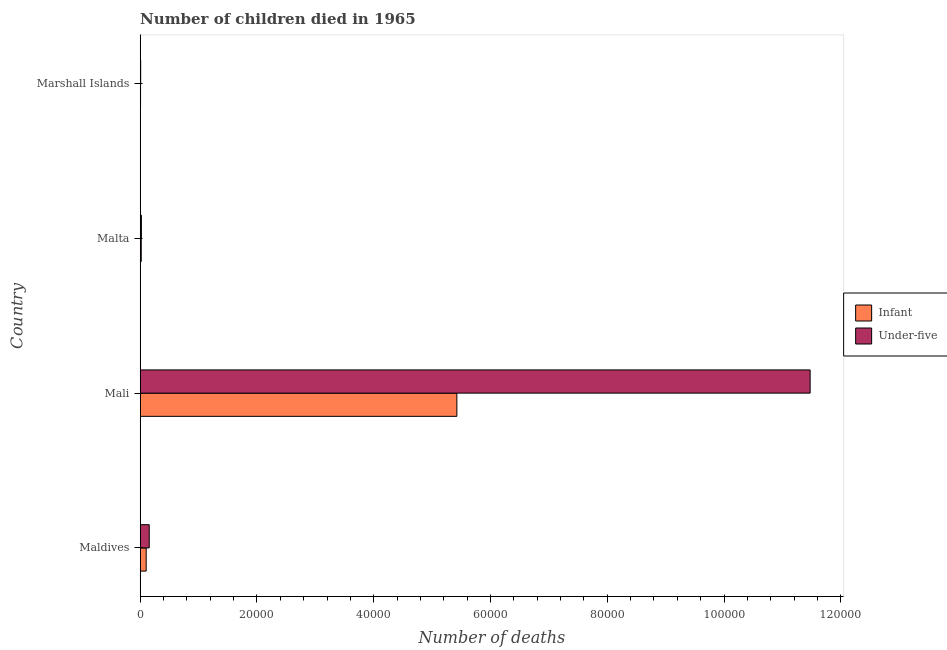How many groups of bars are there?
Ensure brevity in your answer.  4. Are the number of bars on each tick of the Y-axis equal?
Your answer should be compact. Yes. What is the label of the 4th group of bars from the top?
Ensure brevity in your answer.  Maldives. What is the number of infant deaths in Malta?
Your response must be concise. 174. Across all countries, what is the maximum number of infant deaths?
Ensure brevity in your answer.  5.42e+04. Across all countries, what is the minimum number of infant deaths?
Keep it short and to the point. 55. In which country was the number of infant deaths maximum?
Make the answer very short. Mali. In which country was the number of infant deaths minimum?
Offer a very short reply. Marshall Islands. What is the total number of under-five deaths in the graph?
Your answer should be very brief. 1.17e+05. What is the difference between the number of under-five deaths in Maldives and that in Marshall Islands?
Your answer should be compact. 1467. What is the difference between the number of under-five deaths in Mali and the number of infant deaths in Marshall Islands?
Keep it short and to the point. 1.15e+05. What is the average number of infant deaths per country?
Your answer should be compact. 1.39e+04. What is the difference between the number of infant deaths and number of under-five deaths in Marshall Islands?
Your answer should be very brief. -21. In how many countries, is the number of under-five deaths greater than 88000 ?
Provide a short and direct response. 1. What is the ratio of the number of under-five deaths in Mali to that in Marshall Islands?
Offer a very short reply. 1509.86. What is the difference between the highest and the second highest number of under-five deaths?
Your answer should be compact. 1.13e+05. What is the difference between the highest and the lowest number of infant deaths?
Keep it short and to the point. 5.42e+04. Is the sum of the number of under-five deaths in Mali and Marshall Islands greater than the maximum number of infant deaths across all countries?
Make the answer very short. Yes. What does the 2nd bar from the top in Malta represents?
Provide a short and direct response. Infant. What does the 1st bar from the bottom in Marshall Islands represents?
Provide a short and direct response. Infant. Are all the bars in the graph horizontal?
Provide a succinct answer. Yes. What is the difference between two consecutive major ticks on the X-axis?
Provide a succinct answer. 2.00e+04. Does the graph contain grids?
Keep it short and to the point. No. Where does the legend appear in the graph?
Provide a short and direct response. Center right. How are the legend labels stacked?
Your answer should be compact. Vertical. What is the title of the graph?
Your answer should be compact. Number of children died in 1965. What is the label or title of the X-axis?
Ensure brevity in your answer.  Number of deaths. What is the label or title of the Y-axis?
Offer a terse response. Country. What is the Number of deaths in Infant in Maldives?
Provide a short and direct response. 1022. What is the Number of deaths of Under-five in Maldives?
Your response must be concise. 1543. What is the Number of deaths of Infant in Mali?
Your response must be concise. 5.42e+04. What is the Number of deaths of Under-five in Mali?
Keep it short and to the point. 1.15e+05. What is the Number of deaths in Infant in Malta?
Your answer should be very brief. 174. What is the Number of deaths in Under-five in Malta?
Give a very brief answer. 200. What is the Number of deaths of Under-five in Marshall Islands?
Make the answer very short. 76. Across all countries, what is the maximum Number of deaths in Infant?
Make the answer very short. 5.42e+04. Across all countries, what is the maximum Number of deaths in Under-five?
Your answer should be compact. 1.15e+05. What is the total Number of deaths in Infant in the graph?
Provide a short and direct response. 5.55e+04. What is the total Number of deaths of Under-five in the graph?
Offer a very short reply. 1.17e+05. What is the difference between the Number of deaths in Infant in Maldives and that in Mali?
Your response must be concise. -5.32e+04. What is the difference between the Number of deaths in Under-five in Maldives and that in Mali?
Give a very brief answer. -1.13e+05. What is the difference between the Number of deaths of Infant in Maldives and that in Malta?
Keep it short and to the point. 848. What is the difference between the Number of deaths of Under-five in Maldives and that in Malta?
Give a very brief answer. 1343. What is the difference between the Number of deaths in Infant in Maldives and that in Marshall Islands?
Offer a very short reply. 967. What is the difference between the Number of deaths of Under-five in Maldives and that in Marshall Islands?
Your response must be concise. 1467. What is the difference between the Number of deaths in Infant in Mali and that in Malta?
Ensure brevity in your answer.  5.41e+04. What is the difference between the Number of deaths of Under-five in Mali and that in Malta?
Your answer should be compact. 1.15e+05. What is the difference between the Number of deaths of Infant in Mali and that in Marshall Islands?
Your response must be concise. 5.42e+04. What is the difference between the Number of deaths in Under-five in Mali and that in Marshall Islands?
Your response must be concise. 1.15e+05. What is the difference between the Number of deaths in Infant in Malta and that in Marshall Islands?
Give a very brief answer. 119. What is the difference between the Number of deaths in Under-five in Malta and that in Marshall Islands?
Offer a very short reply. 124. What is the difference between the Number of deaths of Infant in Maldives and the Number of deaths of Under-five in Mali?
Provide a short and direct response. -1.14e+05. What is the difference between the Number of deaths in Infant in Maldives and the Number of deaths in Under-five in Malta?
Your answer should be very brief. 822. What is the difference between the Number of deaths of Infant in Maldives and the Number of deaths of Under-five in Marshall Islands?
Your response must be concise. 946. What is the difference between the Number of deaths in Infant in Mali and the Number of deaths in Under-five in Malta?
Offer a very short reply. 5.40e+04. What is the difference between the Number of deaths of Infant in Mali and the Number of deaths of Under-five in Marshall Islands?
Your answer should be compact. 5.42e+04. What is the average Number of deaths of Infant per country?
Ensure brevity in your answer.  1.39e+04. What is the average Number of deaths in Under-five per country?
Your answer should be compact. 2.91e+04. What is the difference between the Number of deaths of Infant and Number of deaths of Under-five in Maldives?
Keep it short and to the point. -521. What is the difference between the Number of deaths of Infant and Number of deaths of Under-five in Mali?
Your answer should be compact. -6.05e+04. What is the difference between the Number of deaths of Infant and Number of deaths of Under-five in Malta?
Make the answer very short. -26. What is the ratio of the Number of deaths in Infant in Maldives to that in Mali?
Your answer should be compact. 0.02. What is the ratio of the Number of deaths in Under-five in Maldives to that in Mali?
Offer a very short reply. 0.01. What is the ratio of the Number of deaths of Infant in Maldives to that in Malta?
Ensure brevity in your answer.  5.87. What is the ratio of the Number of deaths of Under-five in Maldives to that in Malta?
Offer a terse response. 7.71. What is the ratio of the Number of deaths of Infant in Maldives to that in Marshall Islands?
Offer a very short reply. 18.58. What is the ratio of the Number of deaths in Under-five in Maldives to that in Marshall Islands?
Your answer should be compact. 20.3. What is the ratio of the Number of deaths of Infant in Mali to that in Malta?
Offer a very short reply. 311.7. What is the ratio of the Number of deaths in Under-five in Mali to that in Malta?
Offer a terse response. 573.75. What is the ratio of the Number of deaths in Infant in Mali to that in Marshall Islands?
Your answer should be compact. 986.09. What is the ratio of the Number of deaths in Under-five in Mali to that in Marshall Islands?
Ensure brevity in your answer.  1509.86. What is the ratio of the Number of deaths of Infant in Malta to that in Marshall Islands?
Keep it short and to the point. 3.16. What is the ratio of the Number of deaths of Under-five in Malta to that in Marshall Islands?
Keep it short and to the point. 2.63. What is the difference between the highest and the second highest Number of deaths of Infant?
Offer a terse response. 5.32e+04. What is the difference between the highest and the second highest Number of deaths of Under-five?
Keep it short and to the point. 1.13e+05. What is the difference between the highest and the lowest Number of deaths in Infant?
Give a very brief answer. 5.42e+04. What is the difference between the highest and the lowest Number of deaths in Under-five?
Make the answer very short. 1.15e+05. 